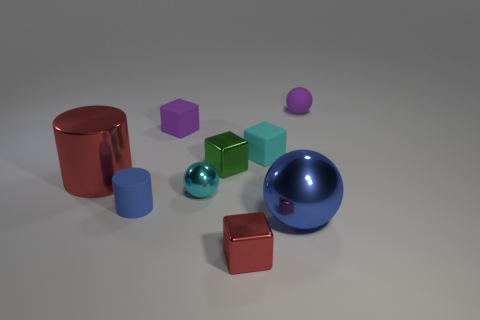Subtract 2 blocks. How many blocks are left? 2 Subtract all cyan rubber blocks. How many blocks are left? 3 Subtract all gray cubes. Subtract all brown spheres. How many cubes are left? 4 Add 1 small objects. How many objects exist? 10 Subtract all balls. How many objects are left? 6 Add 7 purple matte balls. How many purple matte balls are left? 8 Add 5 yellow blocks. How many yellow blocks exist? 5 Subtract 1 cyan cubes. How many objects are left? 8 Subtract all small cyan matte objects. Subtract all small purple rubber cubes. How many objects are left? 7 